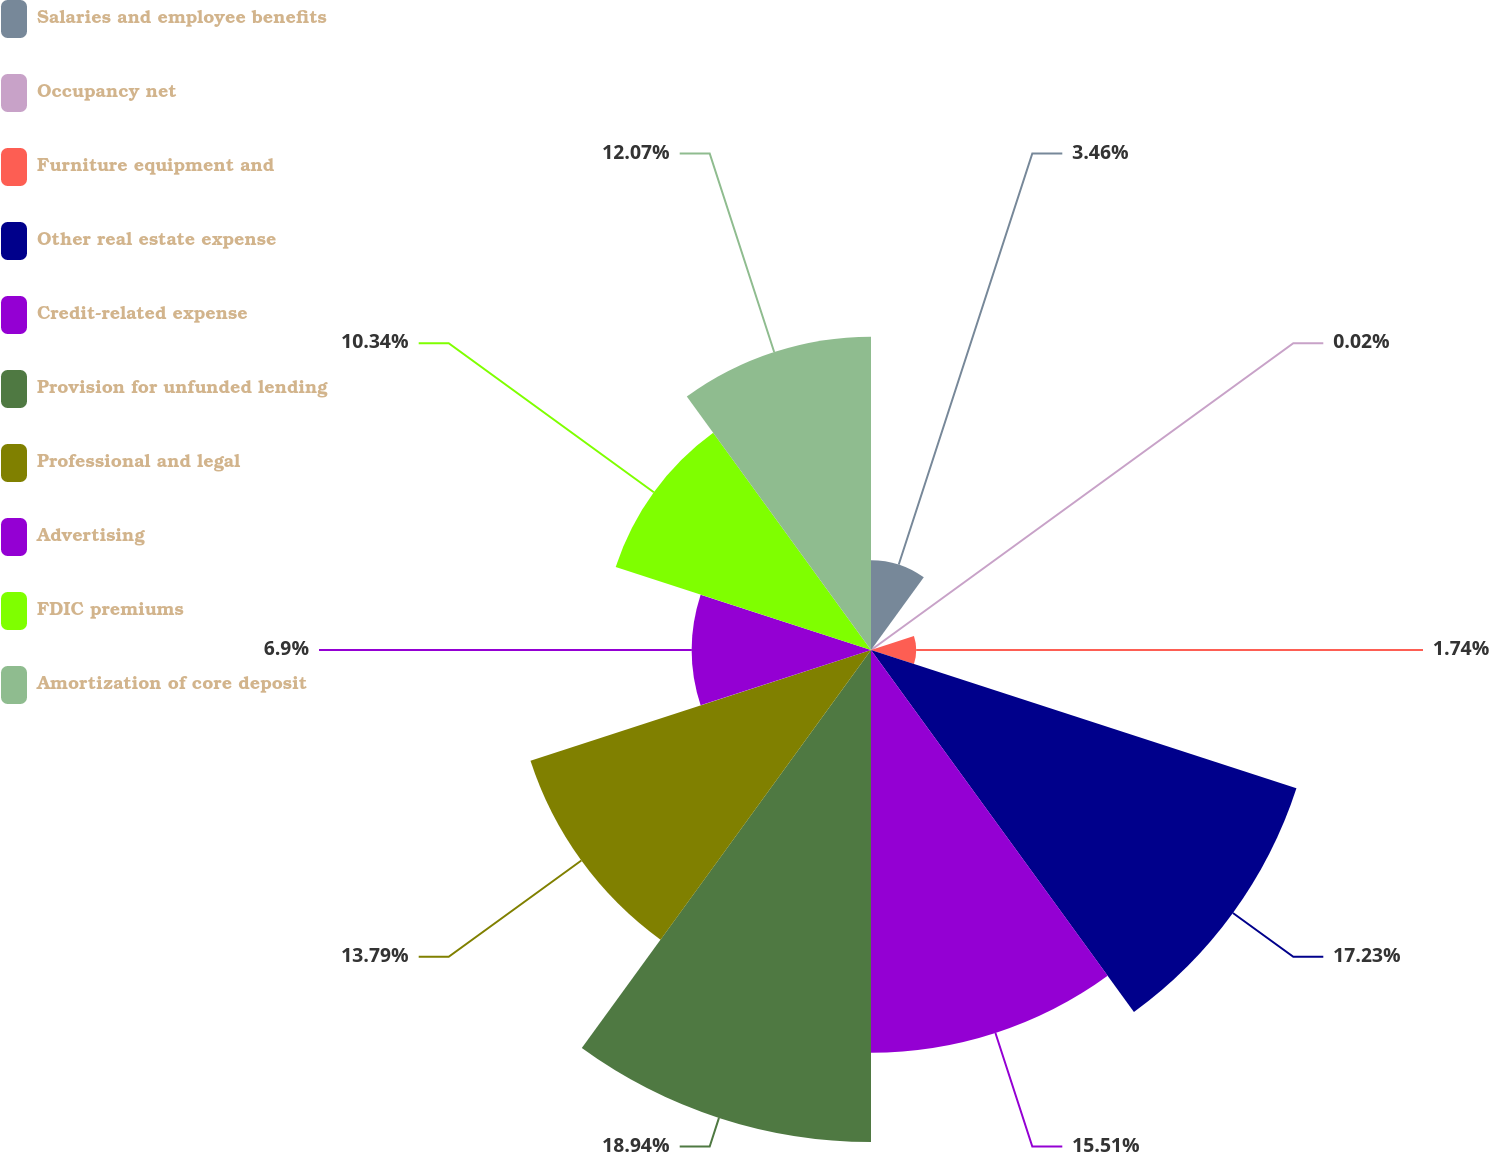Convert chart. <chart><loc_0><loc_0><loc_500><loc_500><pie_chart><fcel>Salaries and employee benefits<fcel>Occupancy net<fcel>Furniture equipment and<fcel>Other real estate expense<fcel>Credit-related expense<fcel>Provision for unfunded lending<fcel>Professional and legal<fcel>Advertising<fcel>FDIC premiums<fcel>Amortization of core deposit<nl><fcel>3.46%<fcel>0.02%<fcel>1.74%<fcel>17.23%<fcel>15.51%<fcel>18.95%<fcel>13.79%<fcel>6.9%<fcel>10.34%<fcel>12.07%<nl></chart> 